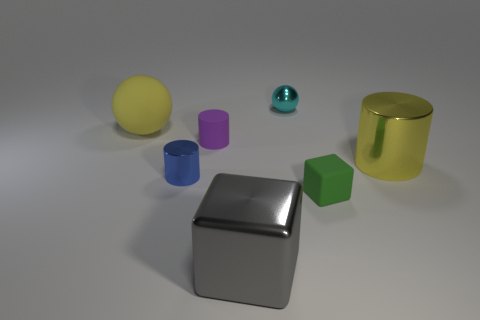Add 2 big yellow metallic things. How many objects exist? 9 Subtract all balls. How many objects are left? 5 Add 3 cyan things. How many cyan things exist? 4 Subtract 0 yellow cubes. How many objects are left? 7 Subtract all large blue shiny cylinders. Subtract all tiny matte cylinders. How many objects are left? 6 Add 1 blue shiny things. How many blue shiny things are left? 2 